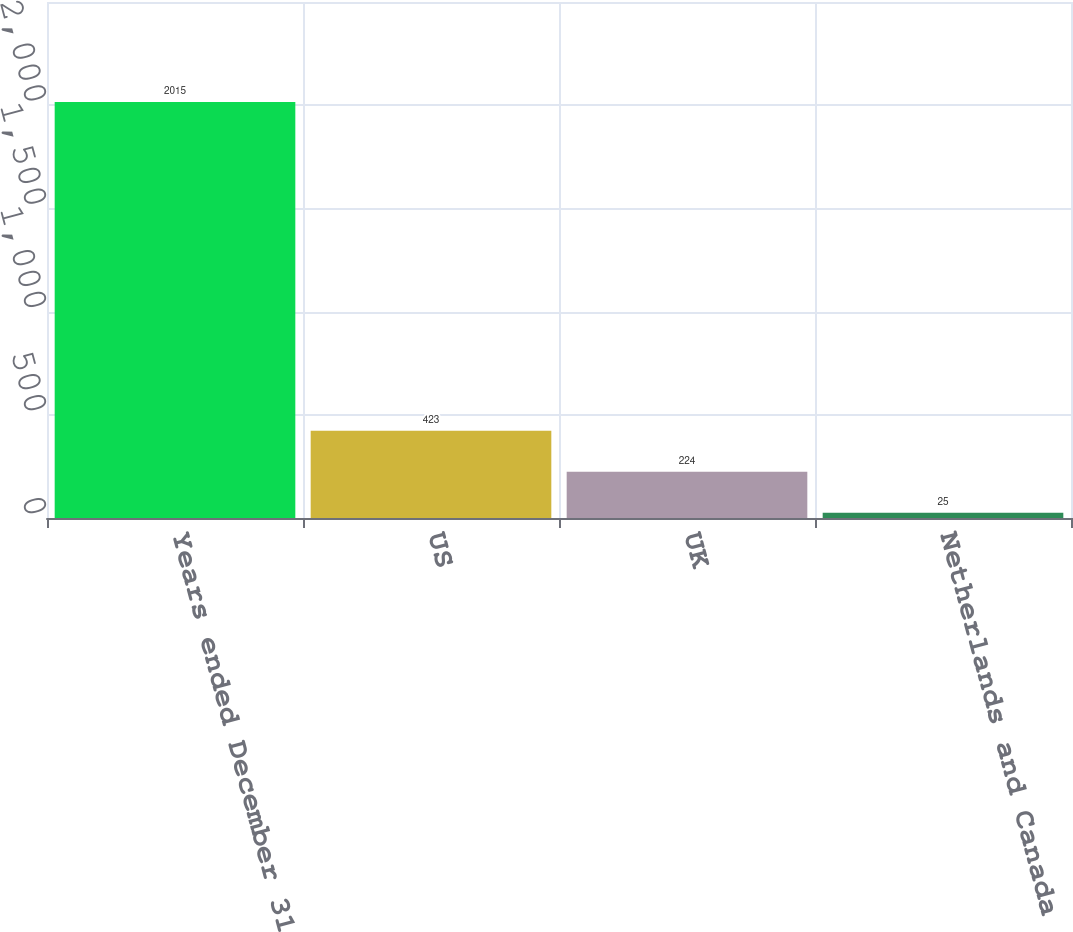Convert chart. <chart><loc_0><loc_0><loc_500><loc_500><bar_chart><fcel>Years ended December 31<fcel>US<fcel>UK<fcel>Netherlands and Canada<nl><fcel>2015<fcel>423<fcel>224<fcel>25<nl></chart> 